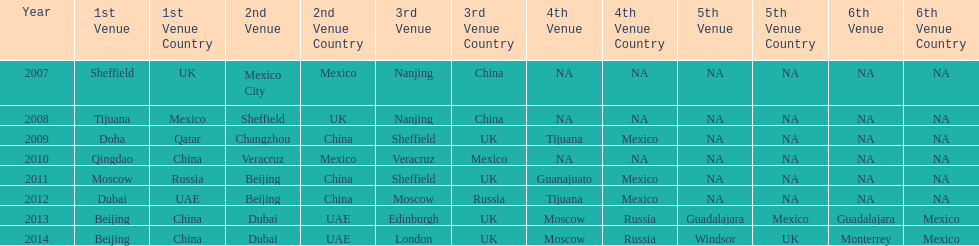In what year was the 3rd venue the same as 2011's 1st venue? 2012. 